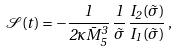Convert formula to latex. <formula><loc_0><loc_0><loc_500><loc_500>\mathcal { S } ( t ) = - \frac { 1 } { 2 \kappa \bar { M } _ { 5 } ^ { 3 } } \, \frac { 1 } { \tilde { \sigma } } \, \frac { I _ { 2 } ( \tilde { \sigma } ) } { I _ { 1 } ( \tilde { \sigma } ) } \, ,</formula> 